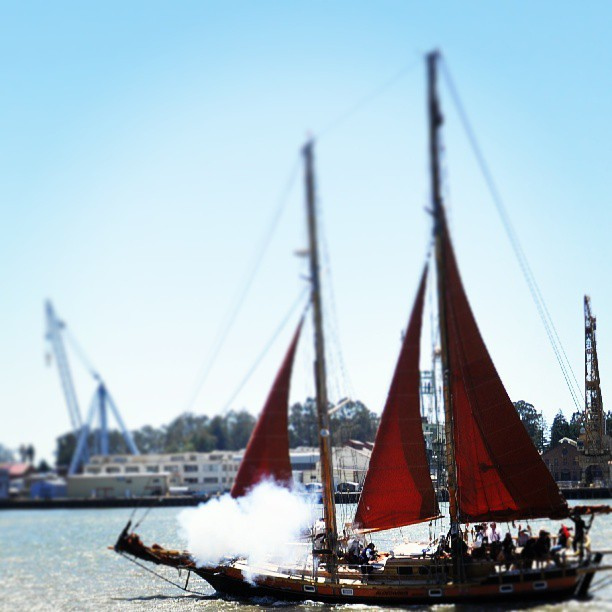<image>Where are there no flag on this ship? It is unknown where there are no flags on this ship. Where are there no flag on this ship? There are flags on this ship. 